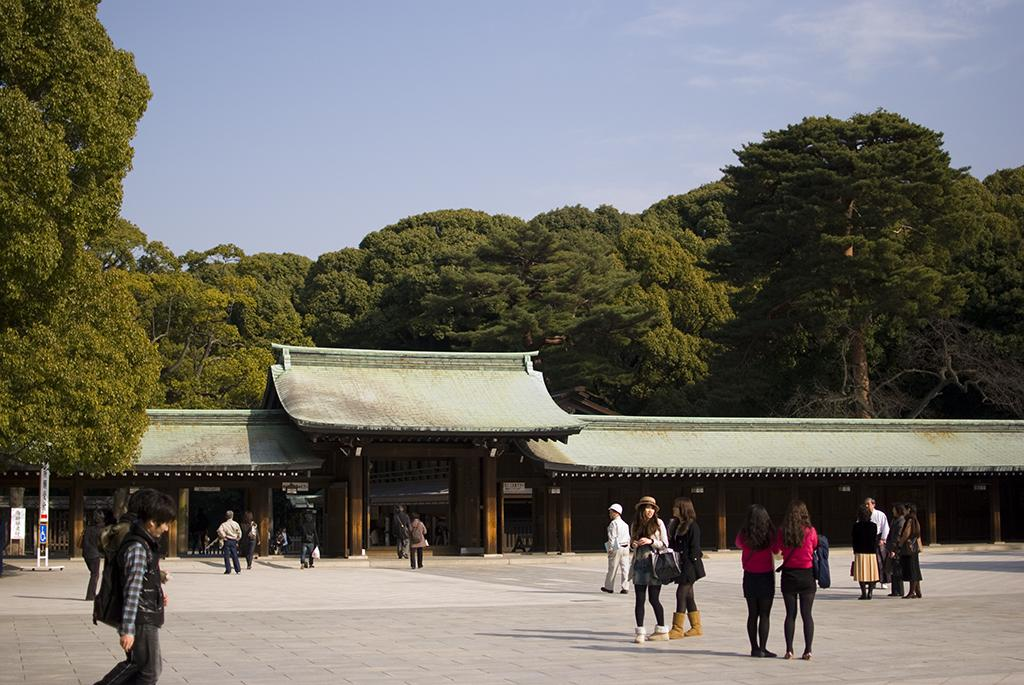What is happening at the bottom of the image? There are people walking at the bottom of the image. What structure is located in the middle of the image? There is a house in the middle of the image. What type of vegetation is at the back side of the image? There are green trees at the back side of the image. What is visible at the top of the image? The sky is visible at the top of the image. What type of cherry is growing on the trees in the image? There are no cherries present in the image; the trees are green. What sound can be heard coming from the house in the image? There is no sound present in the image, as it is a still image. 